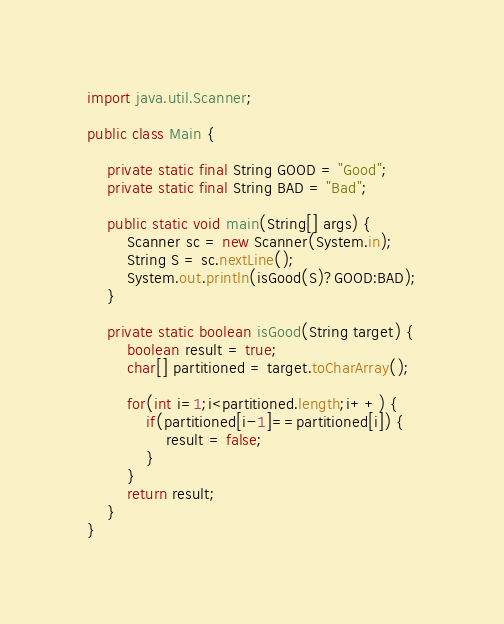Convert code to text. <code><loc_0><loc_0><loc_500><loc_500><_Java_>import java.util.Scanner;

public class Main {
    
    private static final String GOOD = "Good";
    private static final String BAD = "Bad";

    public static void main(String[] args) {
        Scanner sc = new Scanner(System.in);
        String S = sc.nextLine();
        System.out.println(isGood(S)?GOOD:BAD);
    }

    private static boolean isGood(String target) {
        boolean result = true;
        char[] partitioned = target.toCharArray();
        
        for(int i=1;i<partitioned.length;i++) {
            if(partitioned[i-1]==partitioned[i]) {
                result = false;
            }
        }
        return result;
    }
}</code> 